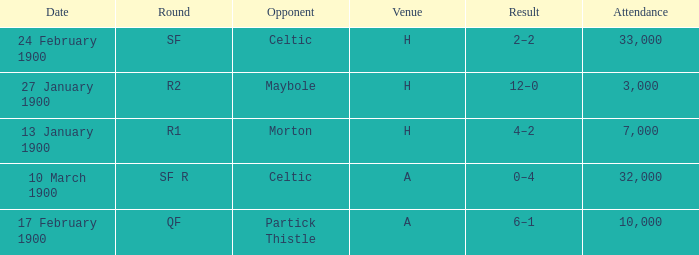Who played against in venue a on 17 february 1900? Partick Thistle. 